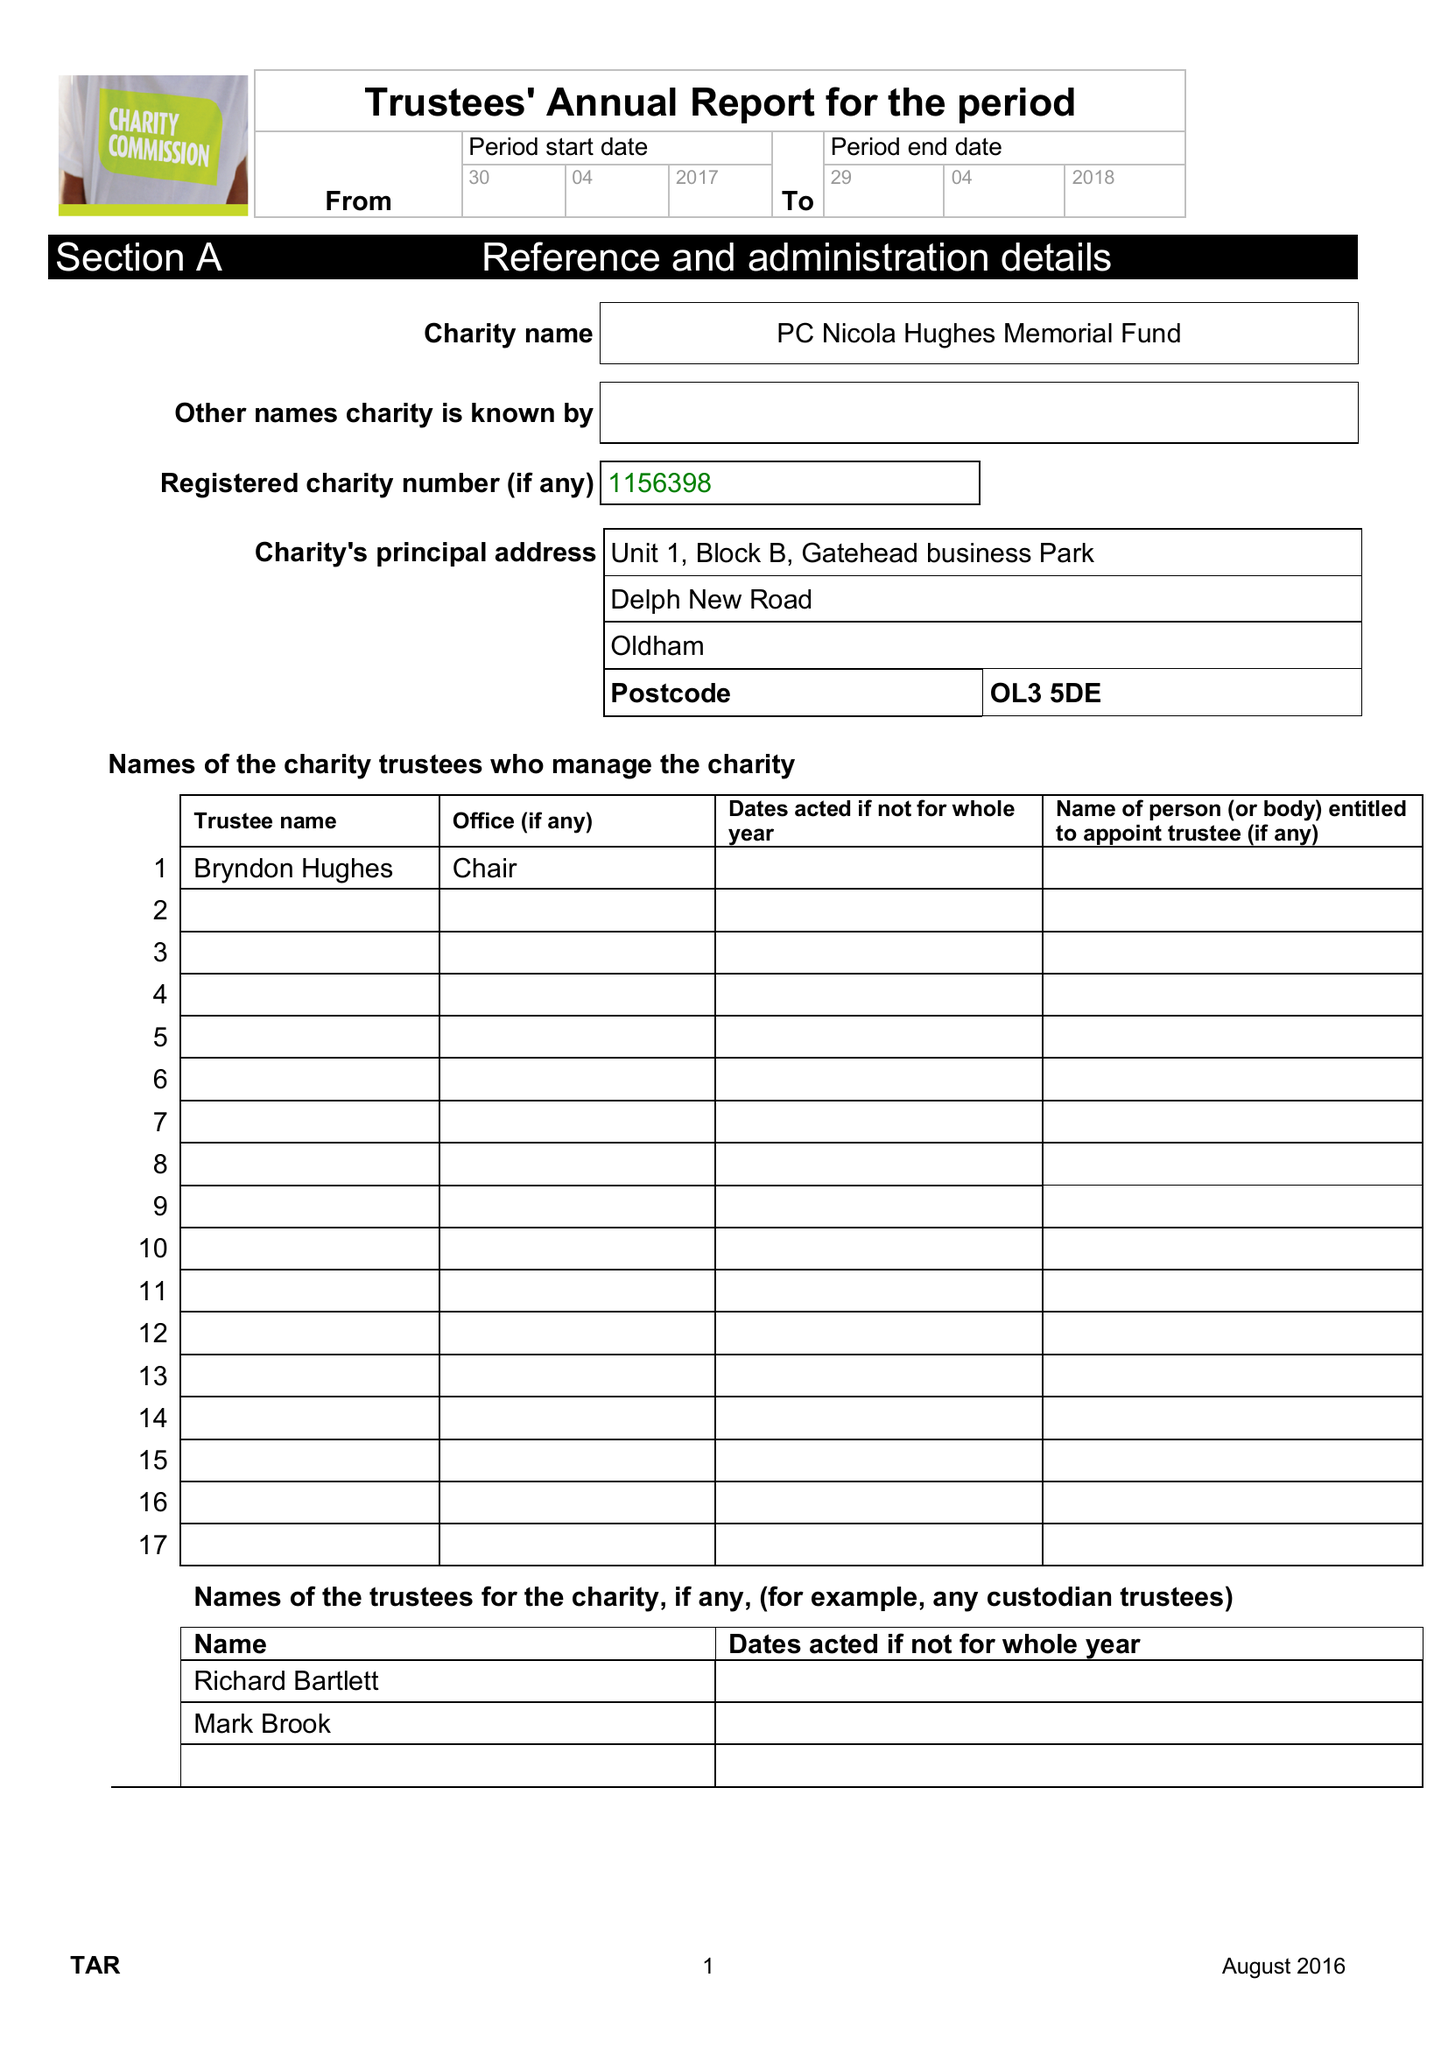What is the value for the address__street_line?
Answer the question using a single word or phrase. DELPH NEW ROAD 